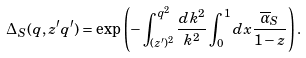Convert formula to latex. <formula><loc_0><loc_0><loc_500><loc_500>\Delta _ { S } ( q , z ^ { \prime } q ^ { \prime } ) = \exp \left ( - \int _ { ( z ^ { \prime } ) ^ { 2 } } ^ { q ^ { 2 } } \frac { d k ^ { 2 } } { k ^ { 2 } } \int _ { 0 } ^ { 1 } d x \frac { { \overline { \alpha } } _ { S } } { 1 - z } \right ) .</formula> 